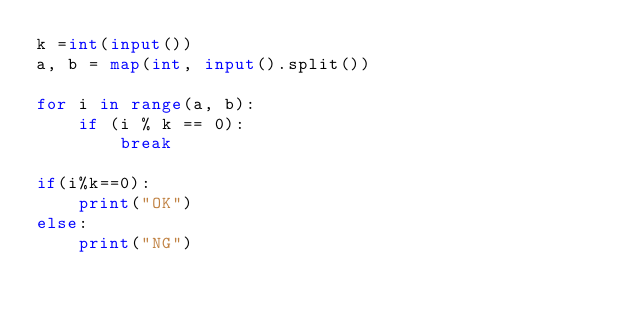<code> <loc_0><loc_0><loc_500><loc_500><_Python_>k =int(input())
a, b = map(int, input().split())

for i in range(a, b):
    if (i % k == 0):
        break
    
if(i%k==0):
    print("OK")
else:
    print("NG")</code> 